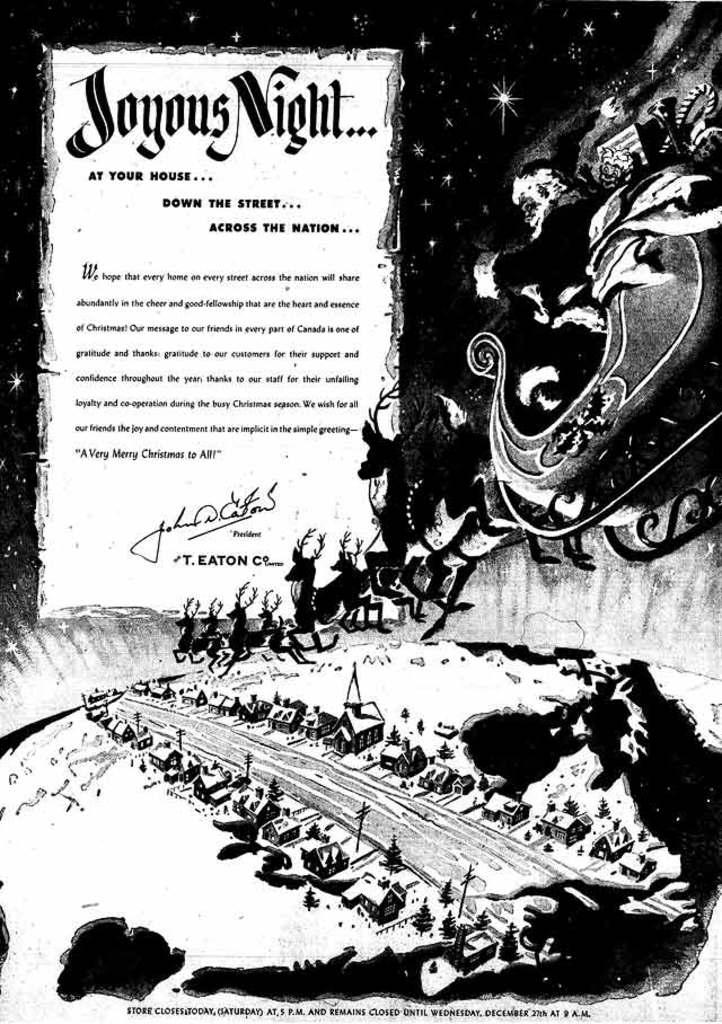Provide a one-sentence caption for the provided image. Santa Claus flying his reindeer over a city and a sign that says Joyous Night. 